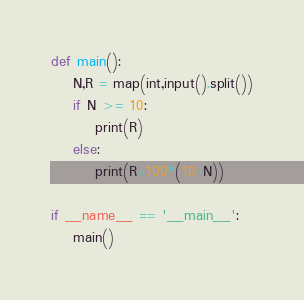Convert code to text. <code><loc_0><loc_0><loc_500><loc_500><_Python_>def main():
    N,R = map(int,input().split())
    if N >= 10:
        print(R)
    else:
        print(R+100*(10-N))

if __name__ == '__main__':
    main()</code> 